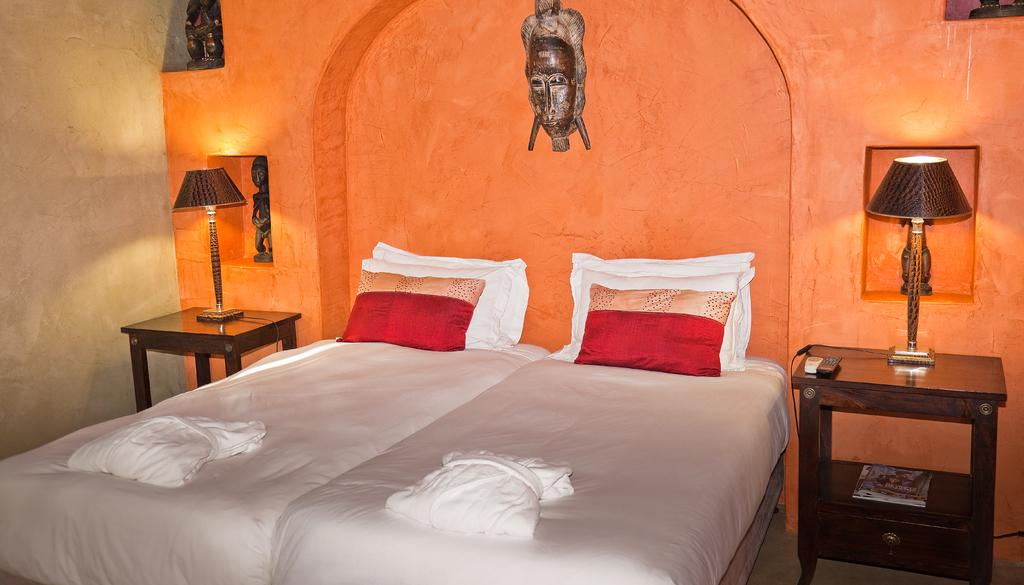What type of room is shown in the image? The image depicts a bedroom. What objects can be seen on a table in the bedroom? There are two lamps on a table in the bedroom. What type of furniture is present on the bed? There are pillows on the bed. What decorative item is mounted on the wall? There is a statue on the wall. What type of flower is growing on the bed in the image? There are no flowers present on the bed in the image. 